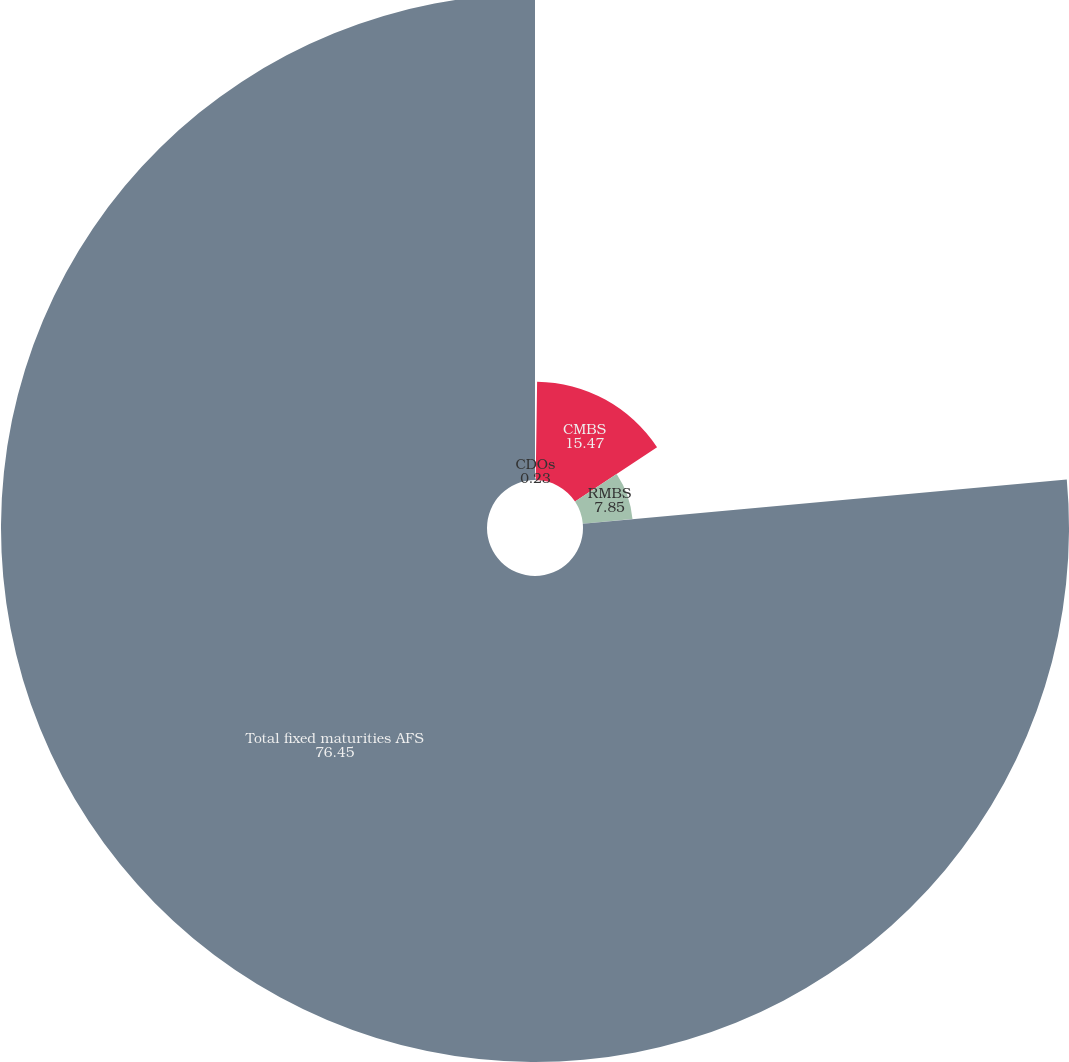Convert chart. <chart><loc_0><loc_0><loc_500><loc_500><pie_chart><fcel>CDOs<fcel>CMBS<fcel>RMBS<fcel>Total fixed maturities AFS<nl><fcel>0.23%<fcel>15.47%<fcel>7.85%<fcel>76.45%<nl></chart> 